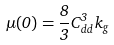<formula> <loc_0><loc_0><loc_500><loc_500>\mu ( 0 ) = \frac { 8 } { 3 } C _ { d d } ^ { 3 } \, k _ { g }</formula> 